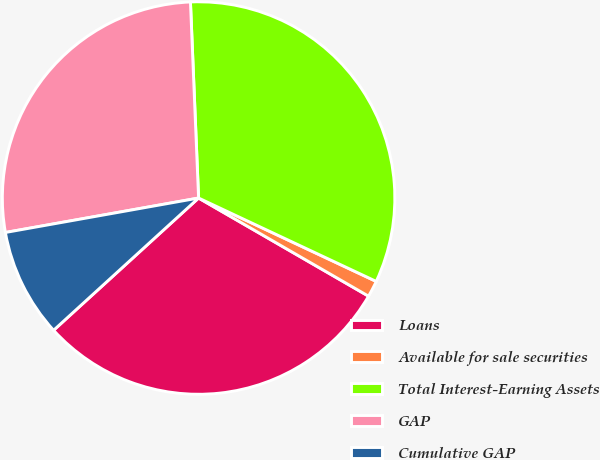<chart> <loc_0><loc_0><loc_500><loc_500><pie_chart><fcel>Loans<fcel>Available for sale securities<fcel>Total Interest-Earning Assets<fcel>GAP<fcel>Cumulative GAP<nl><fcel>29.9%<fcel>1.35%<fcel>32.65%<fcel>27.15%<fcel>8.96%<nl></chart> 